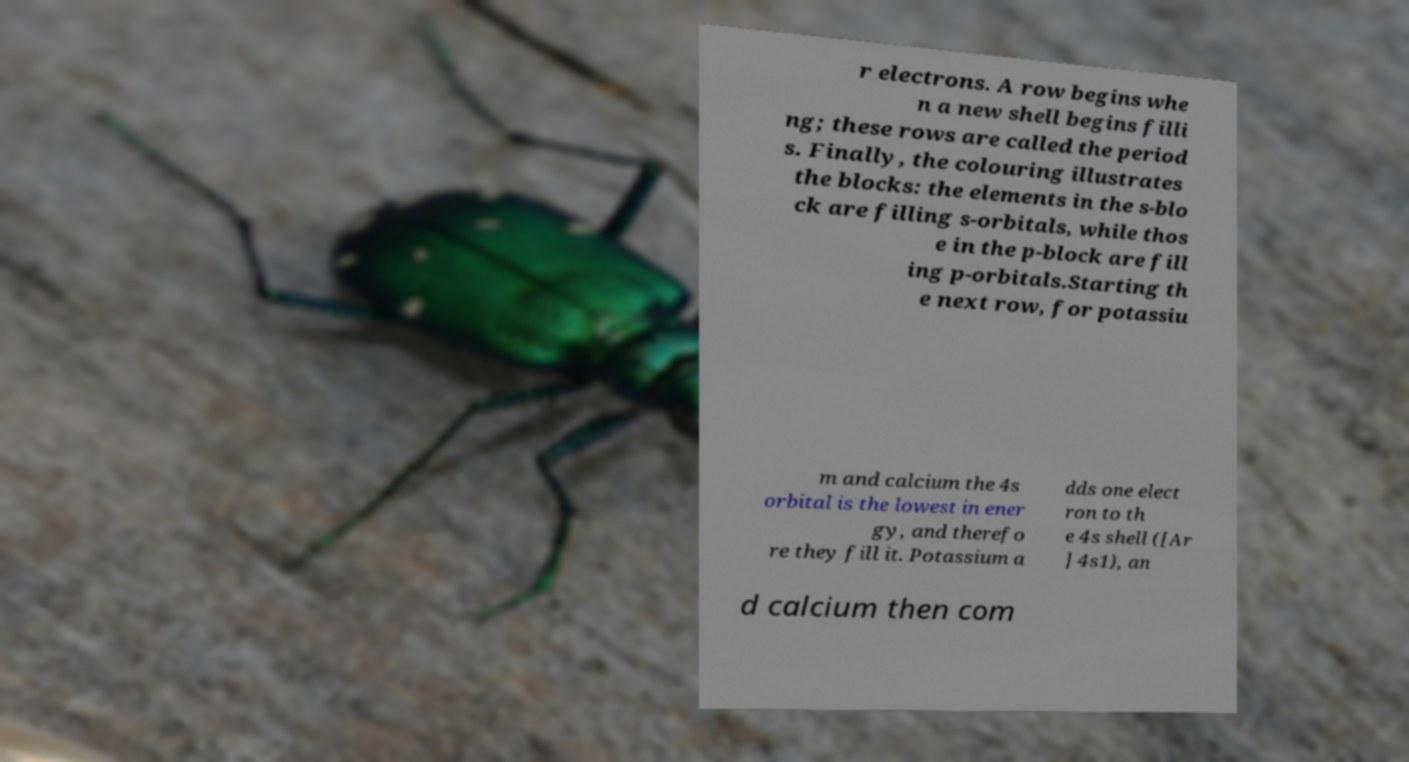Can you read and provide the text displayed in the image?This photo seems to have some interesting text. Can you extract and type it out for me? r electrons. A row begins whe n a new shell begins filli ng; these rows are called the period s. Finally, the colouring illustrates the blocks: the elements in the s-blo ck are filling s-orbitals, while thos e in the p-block are fill ing p-orbitals.Starting th e next row, for potassiu m and calcium the 4s orbital is the lowest in ener gy, and therefo re they fill it. Potassium a dds one elect ron to th e 4s shell ([Ar ] 4s1), an d calcium then com 